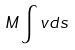<formula> <loc_0><loc_0><loc_500><loc_500>M \int v d s</formula> 